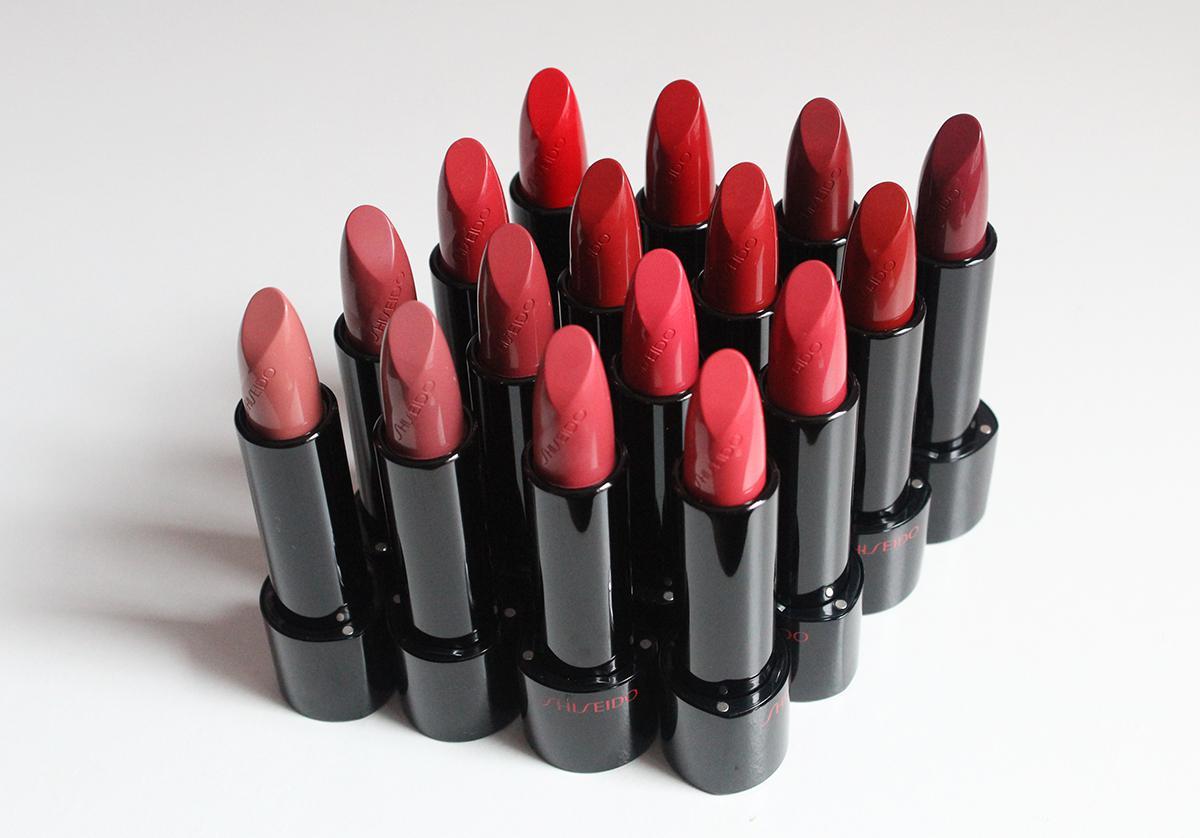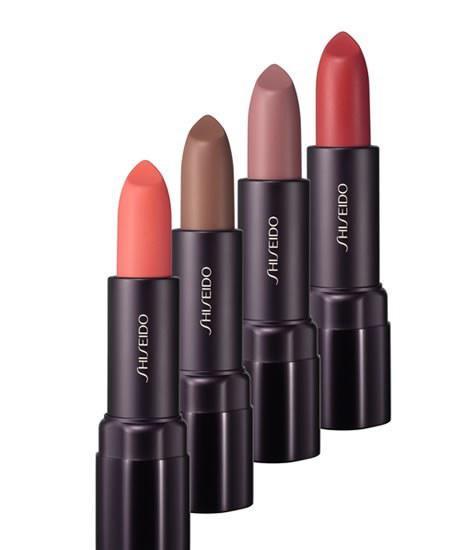The first image is the image on the left, the second image is the image on the right. Given the left and right images, does the statement "There are exactly four lipsticks in the right image." hold true? Answer yes or no. Yes. 